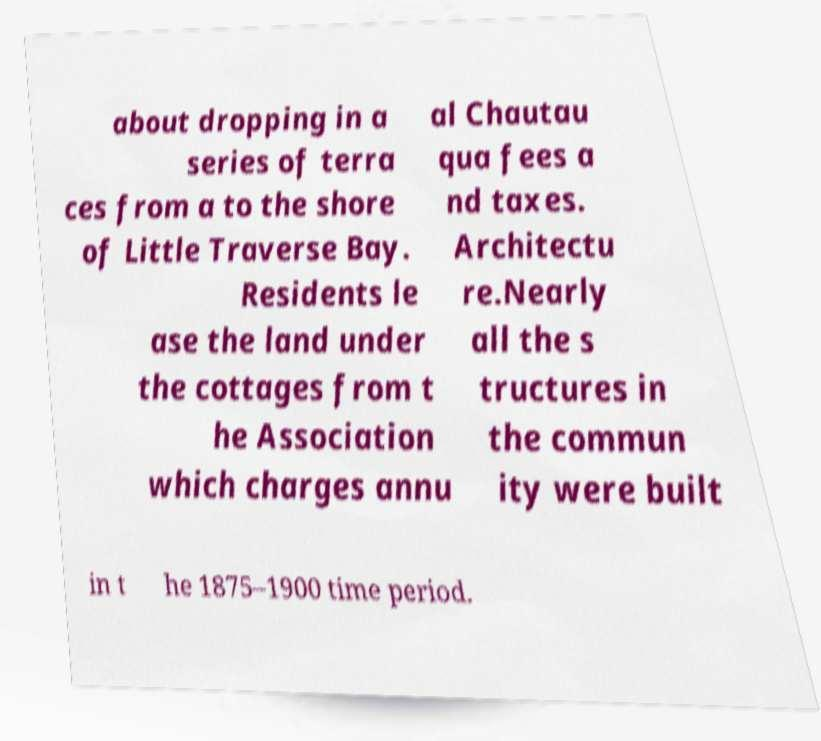Could you extract and type out the text from this image? about dropping in a series of terra ces from a to the shore of Little Traverse Bay. Residents le ase the land under the cottages from t he Association which charges annu al Chautau qua fees a nd taxes. Architectu re.Nearly all the s tructures in the commun ity were built in t he 1875–1900 time period. 